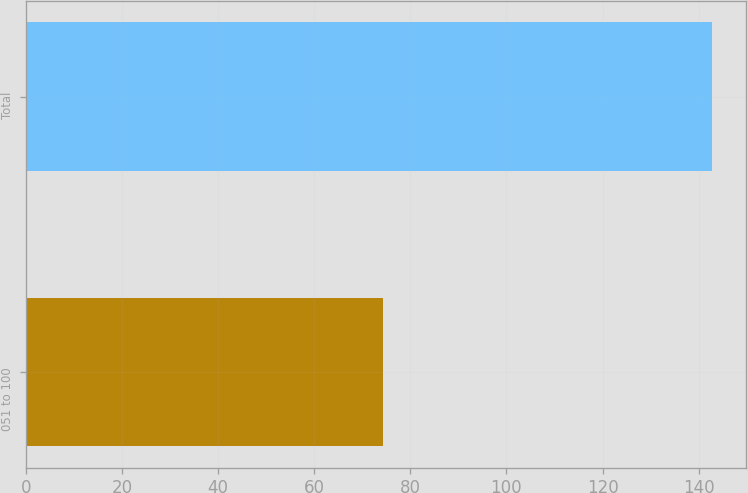Convert chart. <chart><loc_0><loc_0><loc_500><loc_500><bar_chart><fcel>051 to 100<fcel>Total<nl><fcel>74.4<fcel>142.7<nl></chart> 